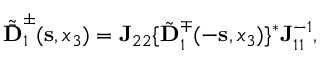<formula> <loc_0><loc_0><loc_500><loc_500>\begin{array} { r } { \tilde { \bar { D } } _ { 1 } ^ { \pm } ( { s } , x _ { 3 } ) = { J } _ { 2 2 } \{ { \tilde { D } } _ { 1 } ^ { \mp } ( - { s } , x _ { 3 } ) \} ^ { * } { J } _ { 1 1 } ^ { - 1 } , } \end{array}</formula> 